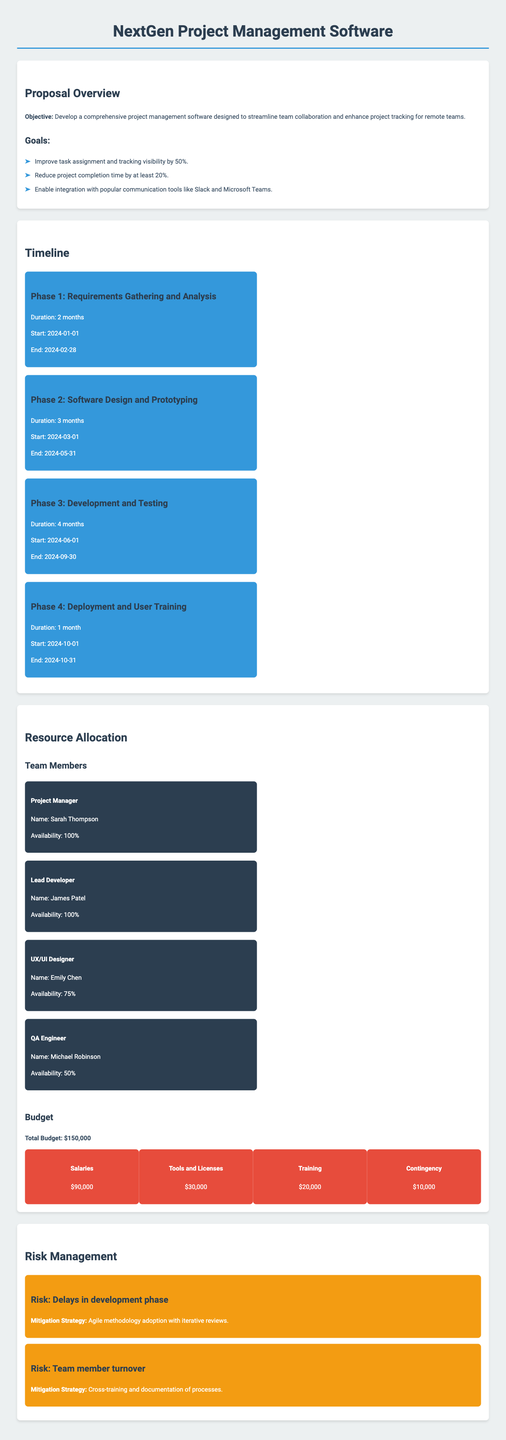What is the main objective of the project? The main objective is to develop comprehensive project management software designed to streamline team collaboration and enhance project tracking for remote teams.
Answer: Comprehensive project management software What is the budget allocated for tools and licenses? The budget section lists the allocation for tools and licenses as part of the total budget.
Answer: $30,000 When does Phase 2 of the project start? The timeline for Phase 2 specifies the start date, which is crucial for tracking project progress.
Answer: 2024-03-01 Who is the Project Manager? The section on resource allocation identifies the Project Manager by name.
Answer: Sarah Thompson What is the duration of Phase 3? The timeline provides specific durations for each phase of the project, and Phase 3 is one of the phases listed.
Answer: 4 months What is the mitigation strategy for delays in the development phase? The risk management section outlines the mitigation strategy mentioned for this specific risk.
Answer: Agile methodology adoption with iterative reviews How many months will the development and testing phase last? The duration for development and testing is indicated in the phases outlined in the timeline section.
Answer: 4 months What percentage availability does the QA Engineer have? The resource allocation section specifies the availability of team members including the QA Engineer.
Answer: 50% 